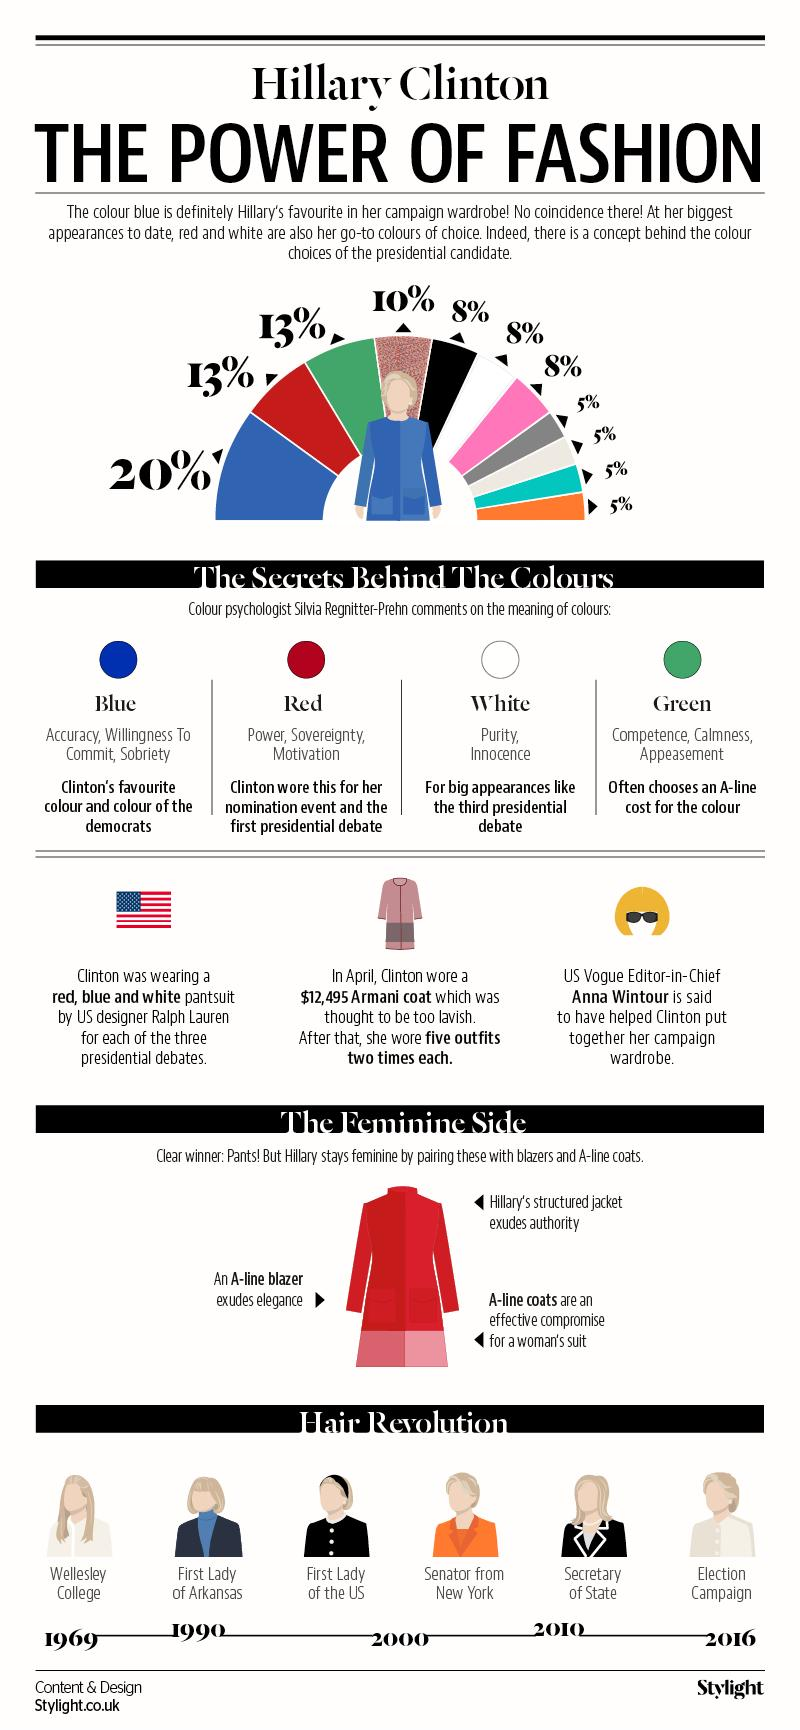Give some essential details in this illustration. Hillary's choice of clothing color for the third presidential debate symbolizes the qualities of purity and innocence. The American flag consists of three colors: red, blue, and white. Hillary Clinton wore her hair long while she was in the position of a student at Wellesley College. A majority of Hillary's dress choices feature blue, with approximately 20% of her outfits containing the color. Hillary's dress is made up of 16% black and white. 